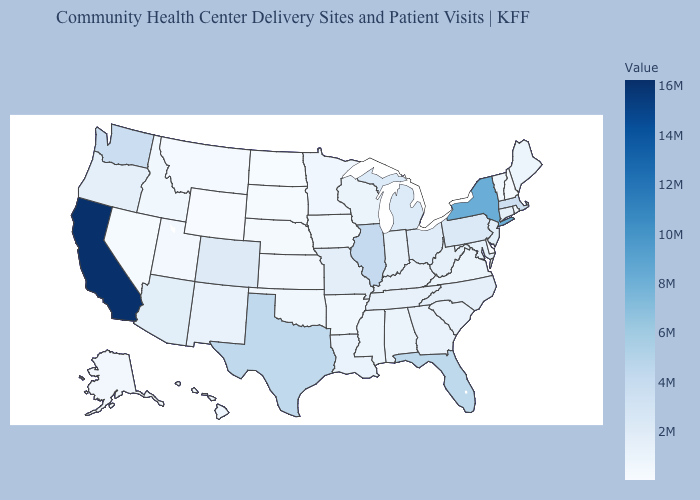Among the states that border North Dakota , which have the lowest value?
Be succinct. South Dakota. Among the states that border Vermont , does Massachusetts have the highest value?
Give a very brief answer. No. Which states have the lowest value in the South?
Be succinct. Delaware. Does Kansas have the highest value in the MidWest?
Answer briefly. No. 